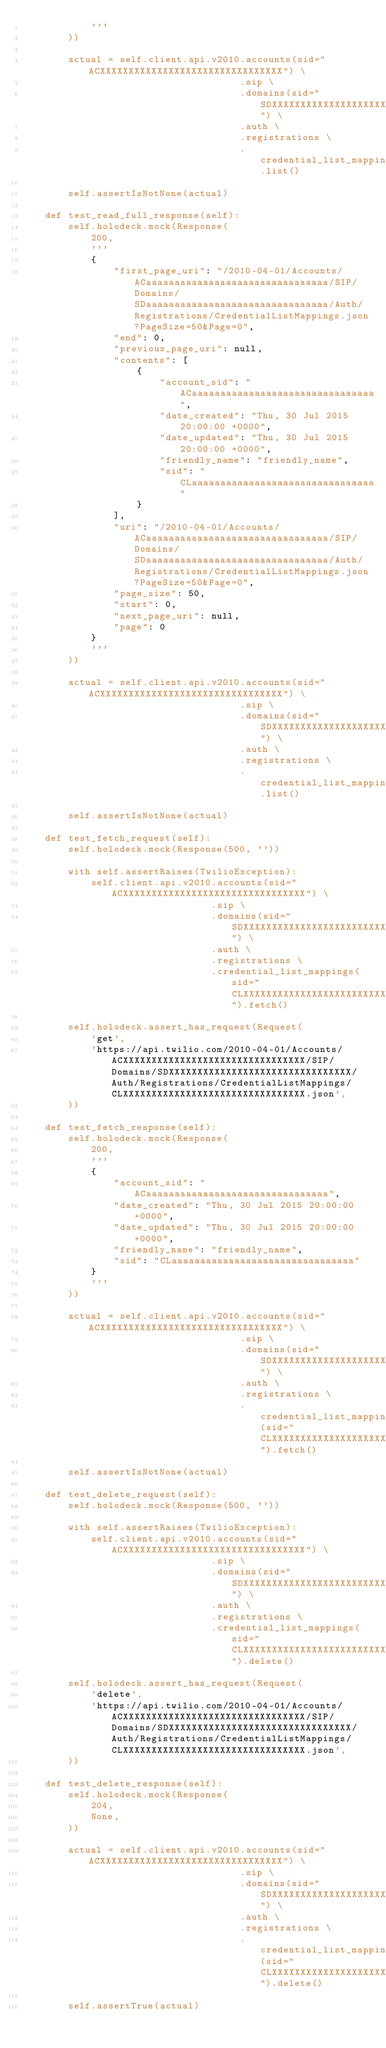Convert code to text. <code><loc_0><loc_0><loc_500><loc_500><_Python_>            '''
        ))

        actual = self.client.api.v2010.accounts(sid="ACXXXXXXXXXXXXXXXXXXXXXXXXXXXXXXXX") \
                                      .sip \
                                      .domains(sid="SDXXXXXXXXXXXXXXXXXXXXXXXXXXXXXXXX") \
                                      .auth \
                                      .registrations \
                                      .credential_list_mappings.list()

        self.assertIsNotNone(actual)

    def test_read_full_response(self):
        self.holodeck.mock(Response(
            200,
            '''
            {
                "first_page_uri": "/2010-04-01/Accounts/ACaaaaaaaaaaaaaaaaaaaaaaaaaaaaaaaa/SIP/Domains/SDaaaaaaaaaaaaaaaaaaaaaaaaaaaaaaaa/Auth/Registrations/CredentialListMappings.json?PageSize=50&Page=0",
                "end": 0,
                "previous_page_uri": null,
                "contents": [
                    {
                        "account_sid": "ACaaaaaaaaaaaaaaaaaaaaaaaaaaaaaaaa",
                        "date_created": "Thu, 30 Jul 2015 20:00:00 +0000",
                        "date_updated": "Thu, 30 Jul 2015 20:00:00 +0000",
                        "friendly_name": "friendly_name",
                        "sid": "CLaaaaaaaaaaaaaaaaaaaaaaaaaaaaaaaa"
                    }
                ],
                "uri": "/2010-04-01/Accounts/ACaaaaaaaaaaaaaaaaaaaaaaaaaaaaaaaa/SIP/Domains/SDaaaaaaaaaaaaaaaaaaaaaaaaaaaaaaaa/Auth/Registrations/CredentialListMappings.json?PageSize=50&Page=0",
                "page_size": 50,
                "start": 0,
                "next_page_uri": null,
                "page": 0
            }
            '''
        ))

        actual = self.client.api.v2010.accounts(sid="ACXXXXXXXXXXXXXXXXXXXXXXXXXXXXXXXX") \
                                      .sip \
                                      .domains(sid="SDXXXXXXXXXXXXXXXXXXXXXXXXXXXXXXXX") \
                                      .auth \
                                      .registrations \
                                      .credential_list_mappings.list()

        self.assertIsNotNone(actual)

    def test_fetch_request(self):
        self.holodeck.mock(Response(500, ''))

        with self.assertRaises(TwilioException):
            self.client.api.v2010.accounts(sid="ACXXXXXXXXXXXXXXXXXXXXXXXXXXXXXXXX") \
                                 .sip \
                                 .domains(sid="SDXXXXXXXXXXXXXXXXXXXXXXXXXXXXXXXX") \
                                 .auth \
                                 .registrations \
                                 .credential_list_mappings(sid="CLXXXXXXXXXXXXXXXXXXXXXXXXXXXXXXXX").fetch()

        self.holodeck.assert_has_request(Request(
            'get',
            'https://api.twilio.com/2010-04-01/Accounts/ACXXXXXXXXXXXXXXXXXXXXXXXXXXXXXXXX/SIP/Domains/SDXXXXXXXXXXXXXXXXXXXXXXXXXXXXXXXX/Auth/Registrations/CredentialListMappings/CLXXXXXXXXXXXXXXXXXXXXXXXXXXXXXXXX.json',
        ))

    def test_fetch_response(self):
        self.holodeck.mock(Response(
            200,
            '''
            {
                "account_sid": "ACaaaaaaaaaaaaaaaaaaaaaaaaaaaaaaaa",
                "date_created": "Thu, 30 Jul 2015 20:00:00 +0000",
                "date_updated": "Thu, 30 Jul 2015 20:00:00 +0000",
                "friendly_name": "friendly_name",
                "sid": "CLaaaaaaaaaaaaaaaaaaaaaaaaaaaaaaaa"
            }
            '''
        ))

        actual = self.client.api.v2010.accounts(sid="ACXXXXXXXXXXXXXXXXXXXXXXXXXXXXXXXX") \
                                      .sip \
                                      .domains(sid="SDXXXXXXXXXXXXXXXXXXXXXXXXXXXXXXXX") \
                                      .auth \
                                      .registrations \
                                      .credential_list_mappings(sid="CLXXXXXXXXXXXXXXXXXXXXXXXXXXXXXXXX").fetch()

        self.assertIsNotNone(actual)

    def test_delete_request(self):
        self.holodeck.mock(Response(500, ''))

        with self.assertRaises(TwilioException):
            self.client.api.v2010.accounts(sid="ACXXXXXXXXXXXXXXXXXXXXXXXXXXXXXXXX") \
                                 .sip \
                                 .domains(sid="SDXXXXXXXXXXXXXXXXXXXXXXXXXXXXXXXX") \
                                 .auth \
                                 .registrations \
                                 .credential_list_mappings(sid="CLXXXXXXXXXXXXXXXXXXXXXXXXXXXXXXXX").delete()

        self.holodeck.assert_has_request(Request(
            'delete',
            'https://api.twilio.com/2010-04-01/Accounts/ACXXXXXXXXXXXXXXXXXXXXXXXXXXXXXXXX/SIP/Domains/SDXXXXXXXXXXXXXXXXXXXXXXXXXXXXXXXX/Auth/Registrations/CredentialListMappings/CLXXXXXXXXXXXXXXXXXXXXXXXXXXXXXXXX.json',
        ))

    def test_delete_response(self):
        self.holodeck.mock(Response(
            204,
            None,
        ))

        actual = self.client.api.v2010.accounts(sid="ACXXXXXXXXXXXXXXXXXXXXXXXXXXXXXXXX") \
                                      .sip \
                                      .domains(sid="SDXXXXXXXXXXXXXXXXXXXXXXXXXXXXXXXX") \
                                      .auth \
                                      .registrations \
                                      .credential_list_mappings(sid="CLXXXXXXXXXXXXXXXXXXXXXXXXXXXXXXXX").delete()

        self.assertTrue(actual)
</code> 